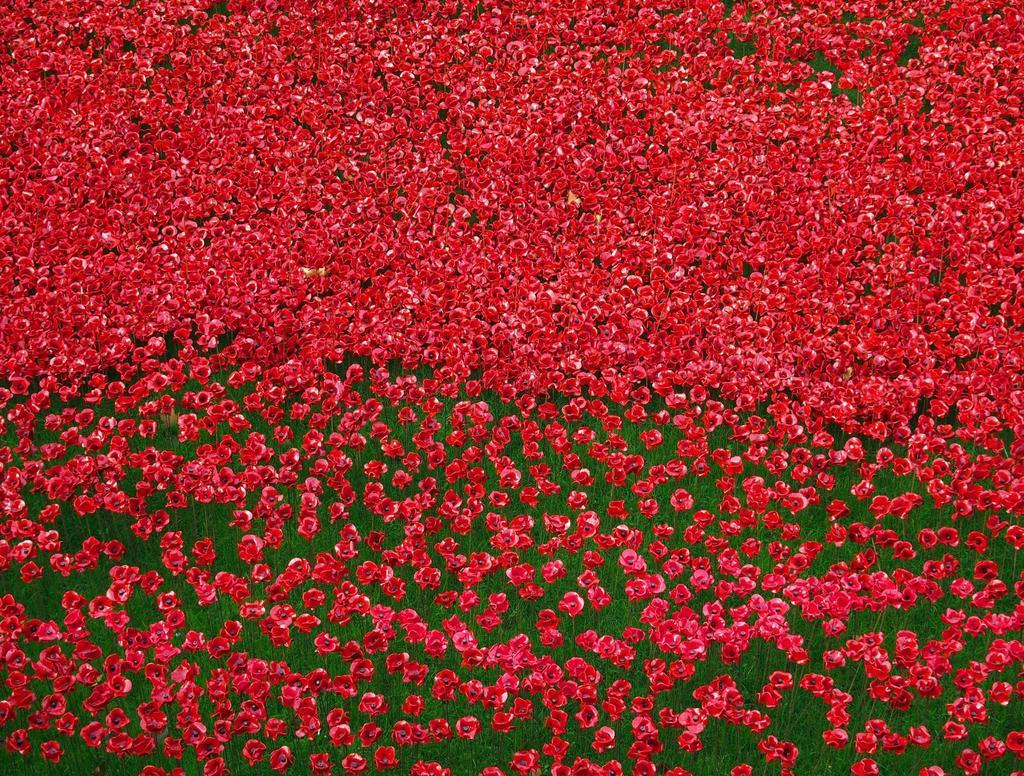What type of flowers can be seen in the image? There are red color flowers in the image. What color are the leaves in the image? There are green color leaves in the image. Reasoning: Let' Let's think step by step in order to produce the conversation. We start by identifying the main subjects in the image, which are the flowers and leaves. Then, we focus on the colors of these subjects, mentioning that the flowers are red and the leaves are green. Each question is designed to elicit a specific detail about the image that is known from the provided facts. Absurd Question/Answer: Can you see any wires tangled among the flowers in the image? There are no wires present in the image; it only features flowers and leaves. How many boys are visible in the image? There are no boys present in the image; it only features flowers and leaves. Are there any bees buzzing around the flowers in the image? There is no indication of bees or any other insects in the image; it only features flowers and leaves. 